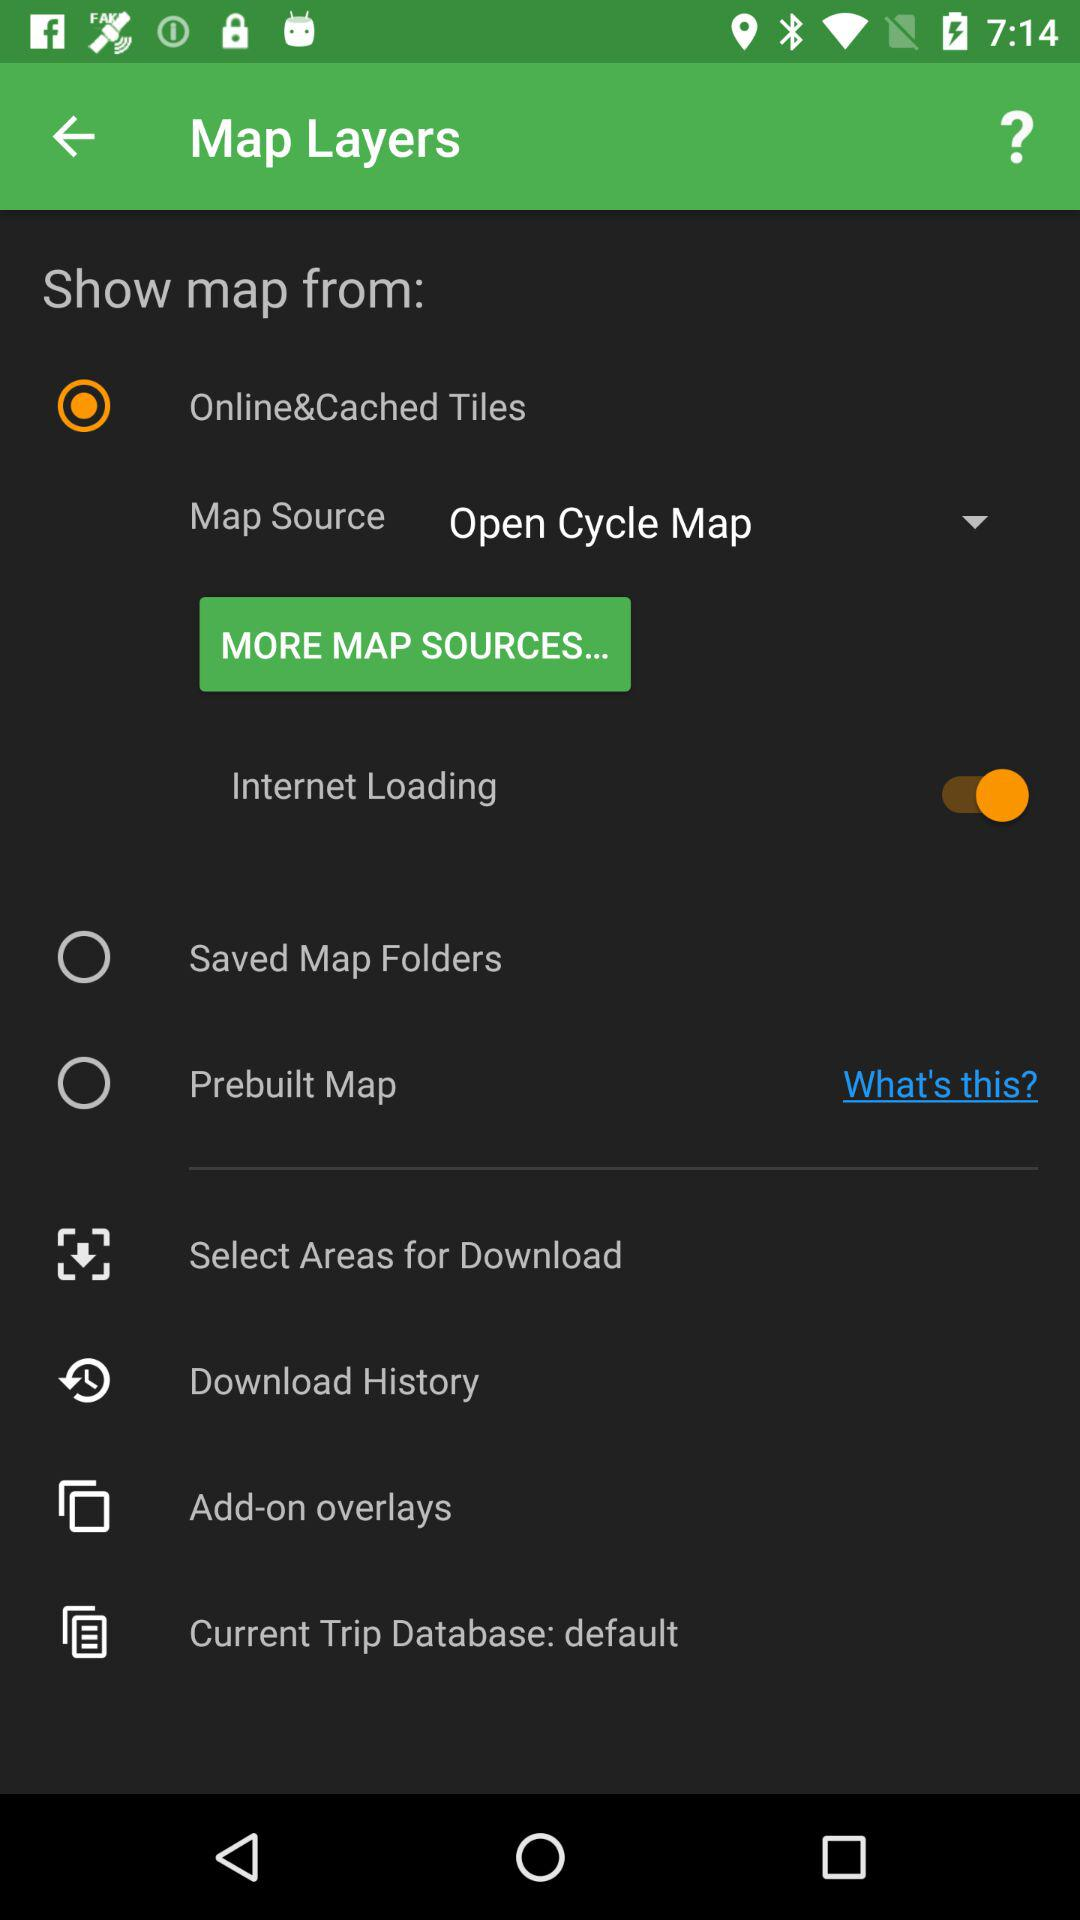What is the status of "Internet Loading"? The status of "Internet Loading" is "on". 